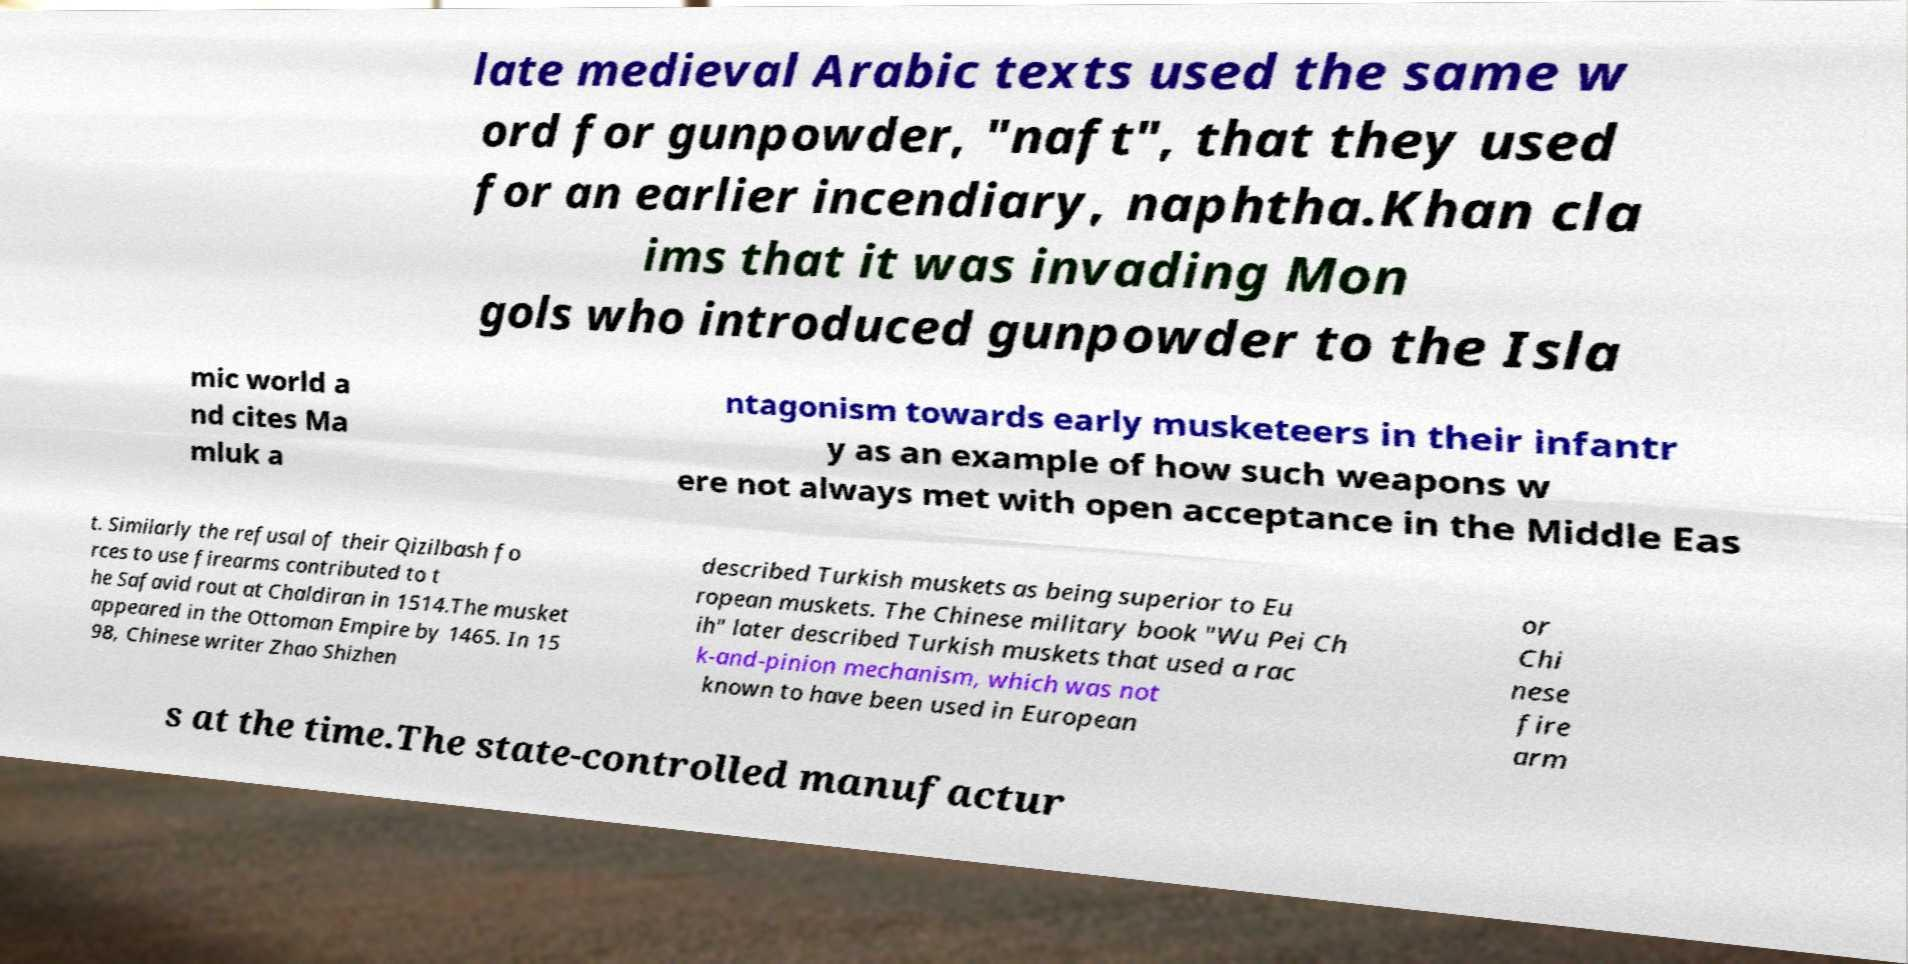For documentation purposes, I need the text within this image transcribed. Could you provide that? late medieval Arabic texts used the same w ord for gunpowder, "naft", that they used for an earlier incendiary, naphtha.Khan cla ims that it was invading Mon gols who introduced gunpowder to the Isla mic world a nd cites Ma mluk a ntagonism towards early musketeers in their infantr y as an example of how such weapons w ere not always met with open acceptance in the Middle Eas t. Similarly the refusal of their Qizilbash fo rces to use firearms contributed to t he Safavid rout at Chaldiran in 1514.The musket appeared in the Ottoman Empire by 1465. In 15 98, Chinese writer Zhao Shizhen described Turkish muskets as being superior to Eu ropean muskets. The Chinese military book "Wu Pei Ch ih" later described Turkish muskets that used a rac k-and-pinion mechanism, which was not known to have been used in European or Chi nese fire arm s at the time.The state-controlled manufactur 